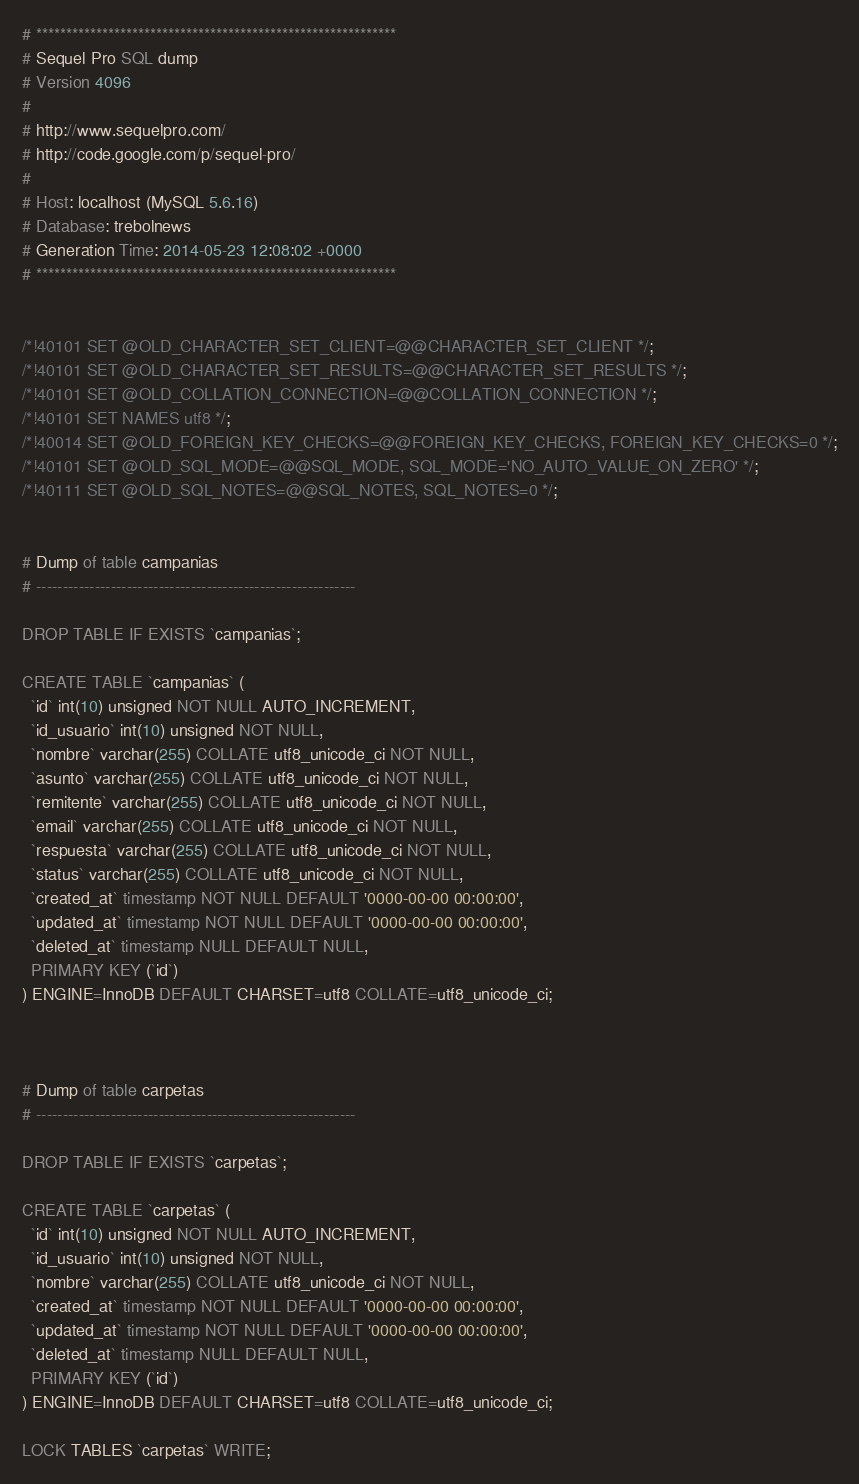<code> <loc_0><loc_0><loc_500><loc_500><_SQL_># ************************************************************
# Sequel Pro SQL dump
# Version 4096
#
# http://www.sequelpro.com/
# http://code.google.com/p/sequel-pro/
#
# Host: localhost (MySQL 5.6.16)
# Database: trebolnews
# Generation Time: 2014-05-23 12:08:02 +0000
# ************************************************************


/*!40101 SET @OLD_CHARACTER_SET_CLIENT=@@CHARACTER_SET_CLIENT */;
/*!40101 SET @OLD_CHARACTER_SET_RESULTS=@@CHARACTER_SET_RESULTS */;
/*!40101 SET @OLD_COLLATION_CONNECTION=@@COLLATION_CONNECTION */;
/*!40101 SET NAMES utf8 */;
/*!40014 SET @OLD_FOREIGN_KEY_CHECKS=@@FOREIGN_KEY_CHECKS, FOREIGN_KEY_CHECKS=0 */;
/*!40101 SET @OLD_SQL_MODE=@@SQL_MODE, SQL_MODE='NO_AUTO_VALUE_ON_ZERO' */;
/*!40111 SET @OLD_SQL_NOTES=@@SQL_NOTES, SQL_NOTES=0 */;


# Dump of table campanias
# ------------------------------------------------------------

DROP TABLE IF EXISTS `campanias`;

CREATE TABLE `campanias` (
  `id` int(10) unsigned NOT NULL AUTO_INCREMENT,
  `id_usuario` int(10) unsigned NOT NULL,
  `nombre` varchar(255) COLLATE utf8_unicode_ci NOT NULL,
  `asunto` varchar(255) COLLATE utf8_unicode_ci NOT NULL,
  `remitente` varchar(255) COLLATE utf8_unicode_ci NOT NULL,
  `email` varchar(255) COLLATE utf8_unicode_ci NOT NULL,
  `respuesta` varchar(255) COLLATE utf8_unicode_ci NOT NULL,
  `status` varchar(255) COLLATE utf8_unicode_ci NOT NULL,
  `created_at` timestamp NOT NULL DEFAULT '0000-00-00 00:00:00',
  `updated_at` timestamp NOT NULL DEFAULT '0000-00-00 00:00:00',
  `deleted_at` timestamp NULL DEFAULT NULL,
  PRIMARY KEY (`id`)
) ENGINE=InnoDB DEFAULT CHARSET=utf8 COLLATE=utf8_unicode_ci;



# Dump of table carpetas
# ------------------------------------------------------------

DROP TABLE IF EXISTS `carpetas`;

CREATE TABLE `carpetas` (
  `id` int(10) unsigned NOT NULL AUTO_INCREMENT,
  `id_usuario` int(10) unsigned NOT NULL,
  `nombre` varchar(255) COLLATE utf8_unicode_ci NOT NULL,
  `created_at` timestamp NOT NULL DEFAULT '0000-00-00 00:00:00',
  `updated_at` timestamp NOT NULL DEFAULT '0000-00-00 00:00:00',
  `deleted_at` timestamp NULL DEFAULT NULL,
  PRIMARY KEY (`id`)
) ENGINE=InnoDB DEFAULT CHARSET=utf8 COLLATE=utf8_unicode_ci;

LOCK TABLES `carpetas` WRITE;</code> 